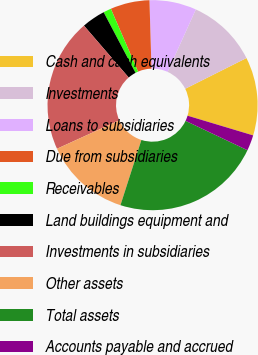Convert chart to OTSL. <chart><loc_0><loc_0><loc_500><loc_500><pie_chart><fcel>Cash and cash equivalents<fcel>Investments<fcel>Loans to subsidiaries<fcel>Due from subsidiaries<fcel>Receivables<fcel>Land buildings equipment and<fcel>Investments in subsidiaries<fcel>Other assets<fcel>Total assets<fcel>Accounts payable and accrued<nl><fcel>12.05%<fcel>10.84%<fcel>7.23%<fcel>6.03%<fcel>1.21%<fcel>3.62%<fcel>20.48%<fcel>13.25%<fcel>22.89%<fcel>2.41%<nl></chart> 